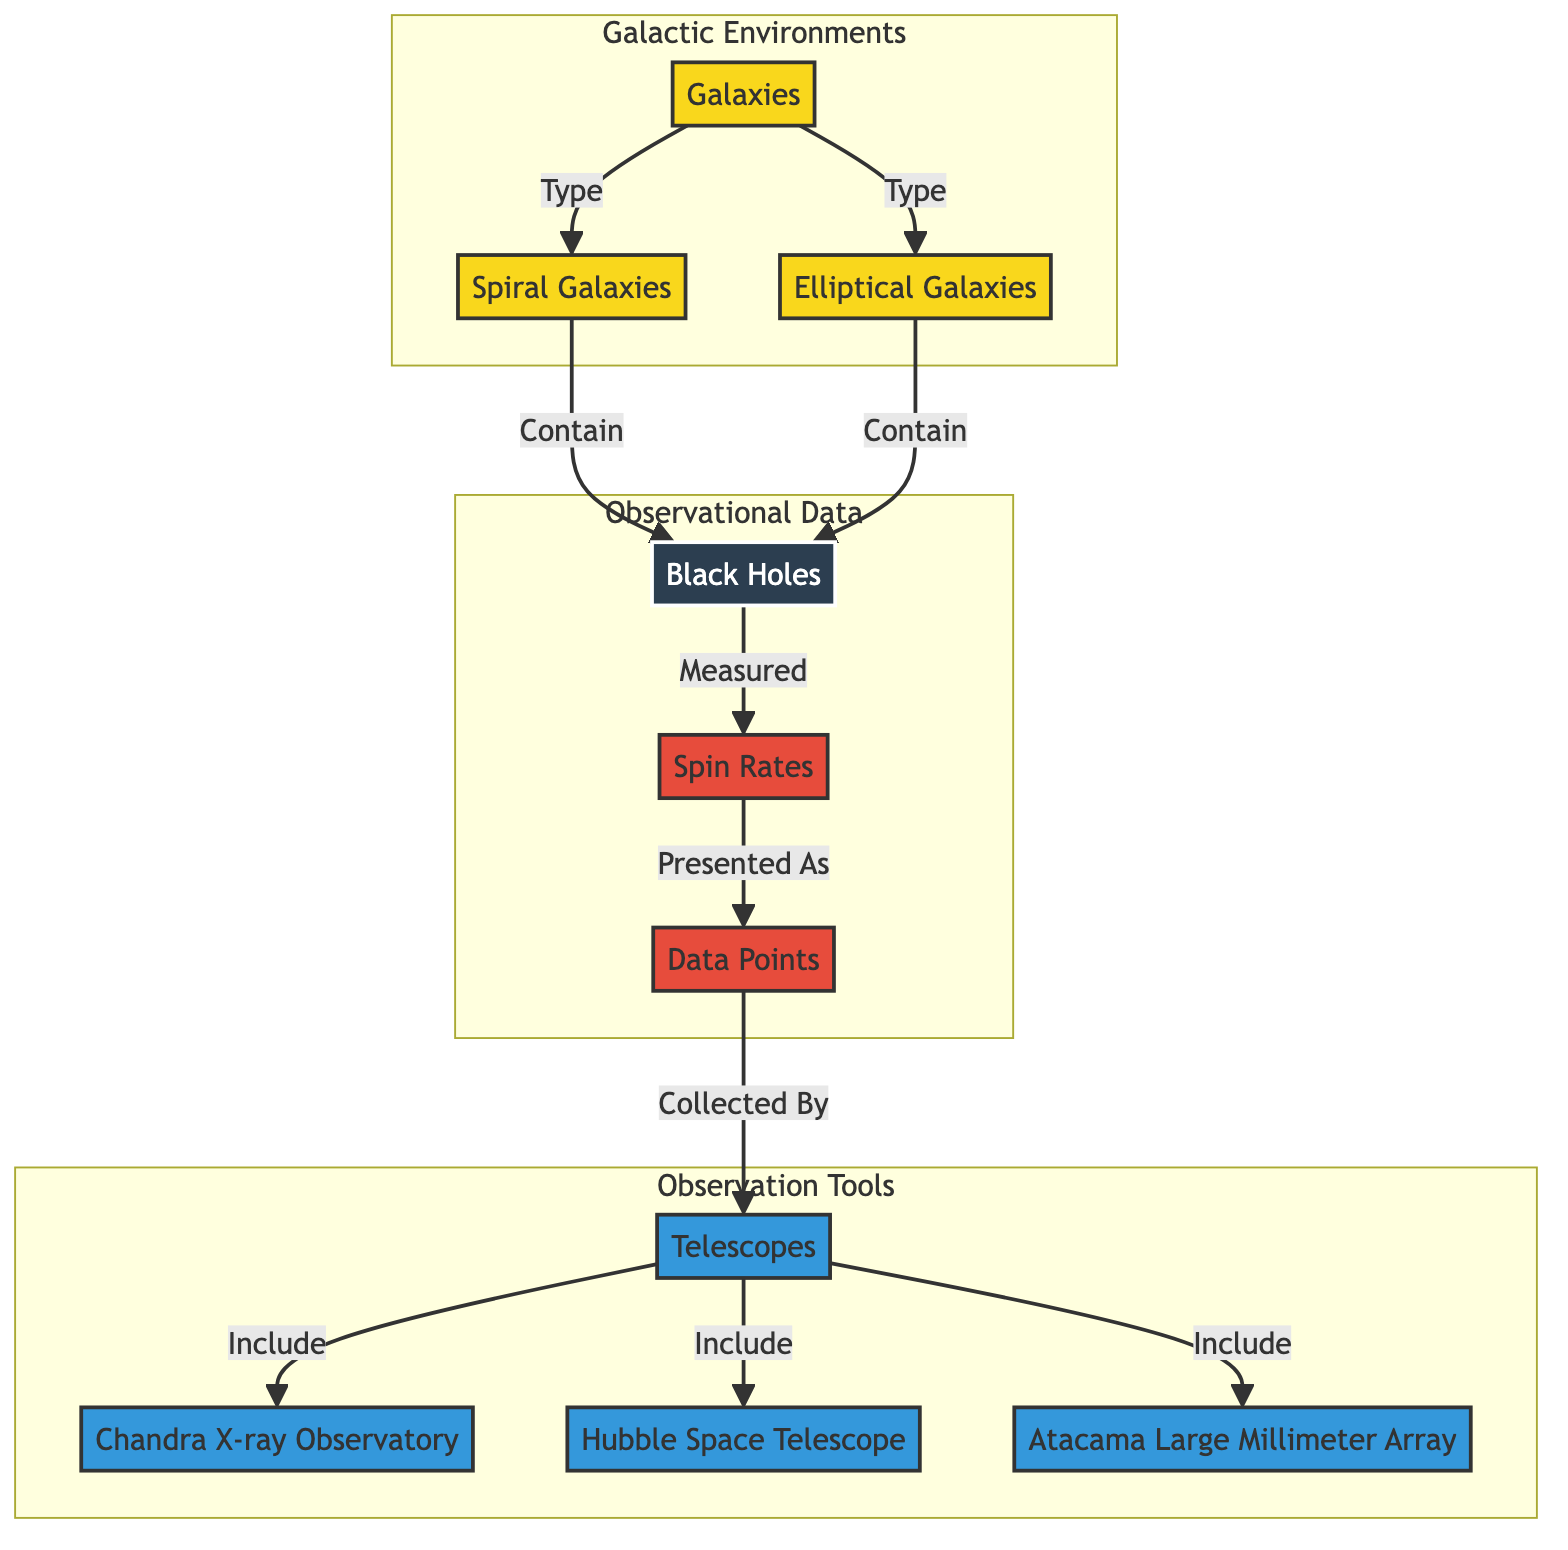What types of galaxies are included in the diagram? The diagram explicitly lists two types of galaxies: Spiral Galaxies and Elliptical Galaxies, both of which are shown as direct descendants under the "Galaxies" node.
Answer: Spiral Galaxies, Elliptical Galaxies How many telescopes are mentioned in the diagram? The diagram features three telescopes specifically labeled: Chandra X-ray Observatory, Hubble Space Telescope, and Atacama Large Millimeter Array. Therefore, counting these gives a total of three telescopes.
Answer: 3 Which type of black holes are associated with spiral galaxies? The diagram indicates that spiral galaxies contain black holes, directly connecting the "Spiral Galaxies" node to the "Black Holes" node, thus linking them.
Answer: Black Holes What is the relationship between black holes and spin rates? The diagram denotes that black holes are the entities whose spin rates are measured, establishing a measurable relationship between the two by drawing a directed connection from "Black Holes" to "Spin Rates."
Answer: Measured How are data points collected according to the diagram? The diagram shows that data points, represented under "Observational Data," are collected by telescopes, as indicated by the arrow linking "Data Points" to "Telescopes."
Answer: Collected By What observational environments are included in the diagram? The diagram categorizes the observational environments into two groups: Spiral Galaxies and Elliptical Galaxies, which are both enclosed in the "Galactic Environments" subgraph.
Answer: Spiral Galaxies, Elliptical Galaxies Which telescopes are part of the observational tools? The diagram identifies three telescopes: Chandra X-ray Observatory, Hubble Space Telescope, and Atacama Large Millimeter Array, as parts of the observational tools indicated in the "Observation Tools" subgraph.
Answer: Chandra X-ray Observatory, Hubble Space Telescope, Atacama Large Millimeter Array What is the flow from galaxies to spin rates in the diagram? The flow starts at "Galaxies," which branches into "Spiral Galaxies" and "Elliptical Galaxies," both of which lead to "Black Holes," and subsequently to "Spin Rates," creating a pathway from galaxies through black holes to spin rates.
Answer: Galaxies → Black Holes → Spin Rates 